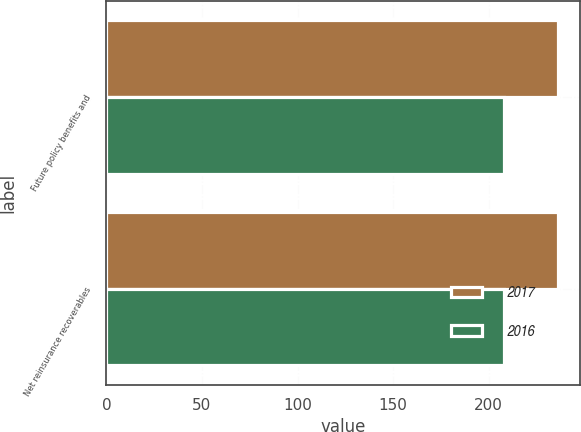<chart> <loc_0><loc_0><loc_500><loc_500><stacked_bar_chart><ecel><fcel>Future policy benefits and<fcel>Net reinsurance recoverables<nl><fcel>2017<fcel>236<fcel>236<nl><fcel>2016<fcel>208<fcel>208<nl></chart> 